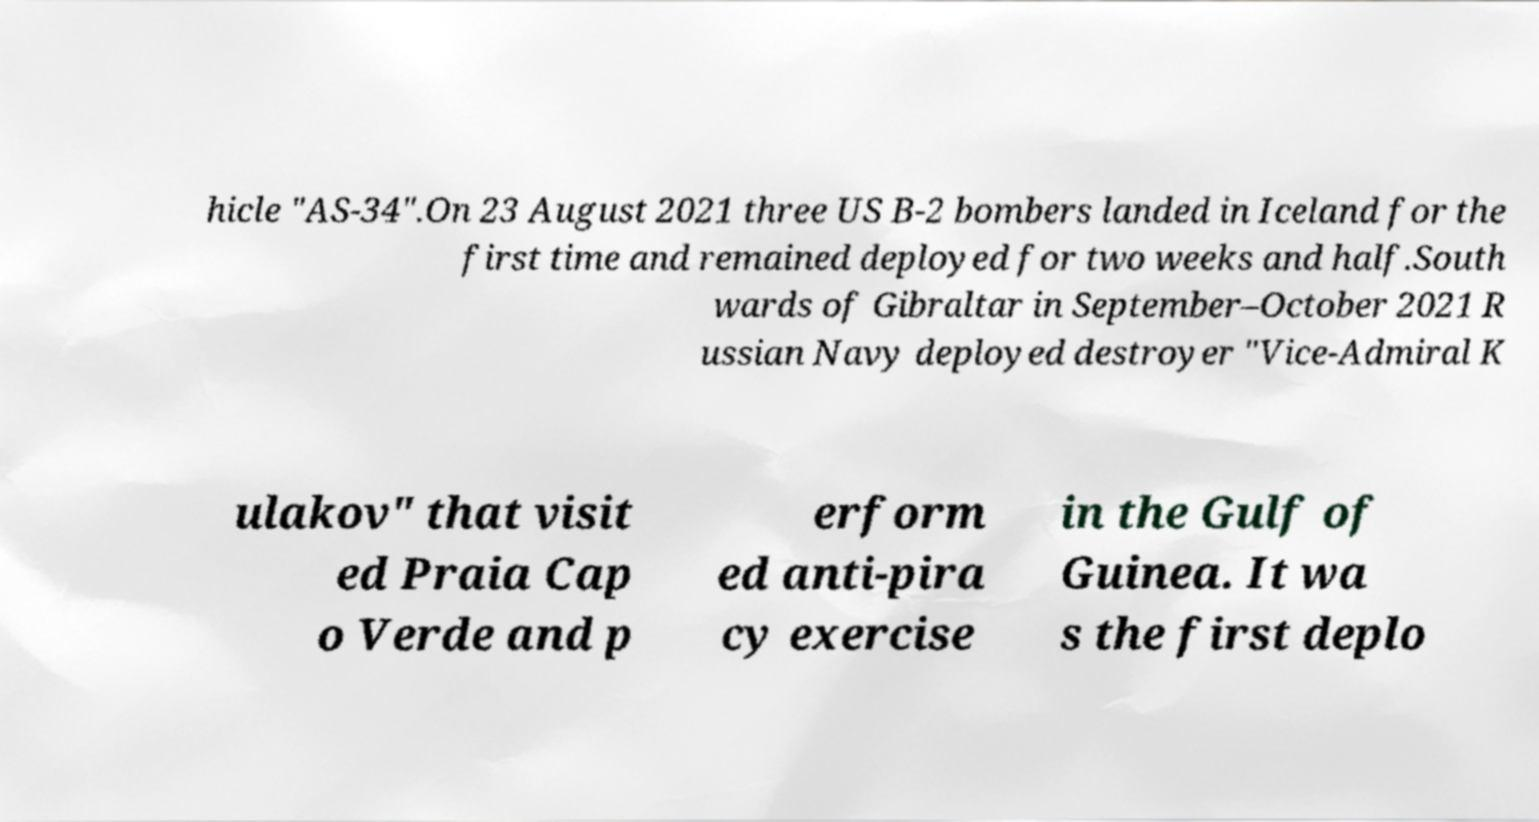Could you extract and type out the text from this image? hicle "AS-34".On 23 August 2021 three US B-2 bombers landed in Iceland for the first time and remained deployed for two weeks and half.South wards of Gibraltar in September–October 2021 R ussian Navy deployed destroyer "Vice-Admiral K ulakov" that visit ed Praia Cap o Verde and p erform ed anti-pira cy exercise in the Gulf of Guinea. It wa s the first deplo 